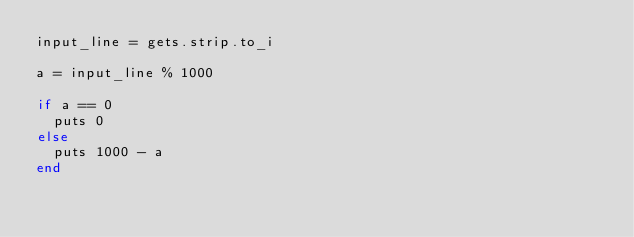<code> <loc_0><loc_0><loc_500><loc_500><_Ruby_>input_line = gets.strip.to_i

a = input_line % 1000

if a == 0
  puts 0
else
  puts 1000 - a
end</code> 